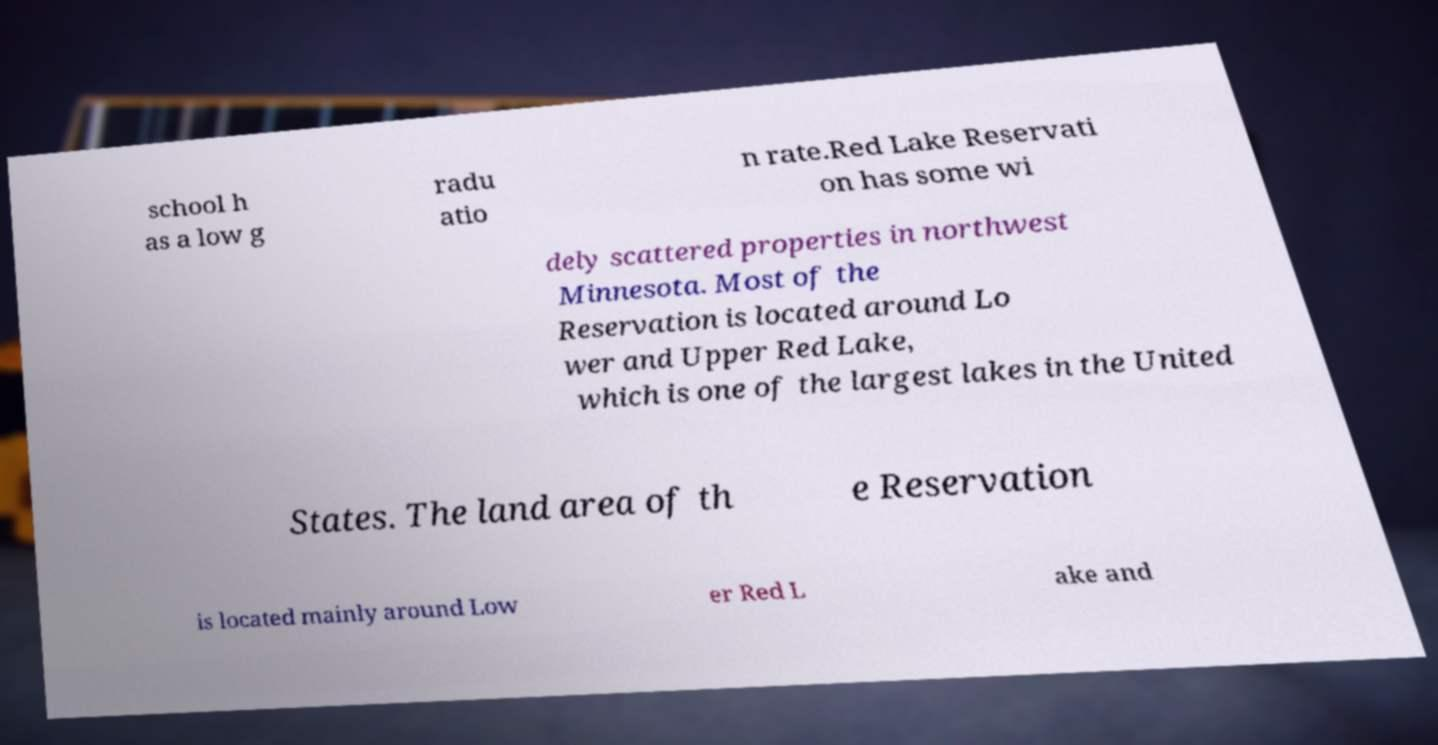There's text embedded in this image that I need extracted. Can you transcribe it verbatim? school h as a low g radu atio n rate.Red Lake Reservati on has some wi dely scattered properties in northwest Minnesota. Most of the Reservation is located around Lo wer and Upper Red Lake, which is one of the largest lakes in the United States. The land area of th e Reservation is located mainly around Low er Red L ake and 